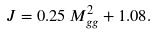Convert formula to latex. <formula><loc_0><loc_0><loc_500><loc_500>J = 0 . 2 5 \, M ^ { 2 } _ { g g } + 1 . 0 8 .</formula> 